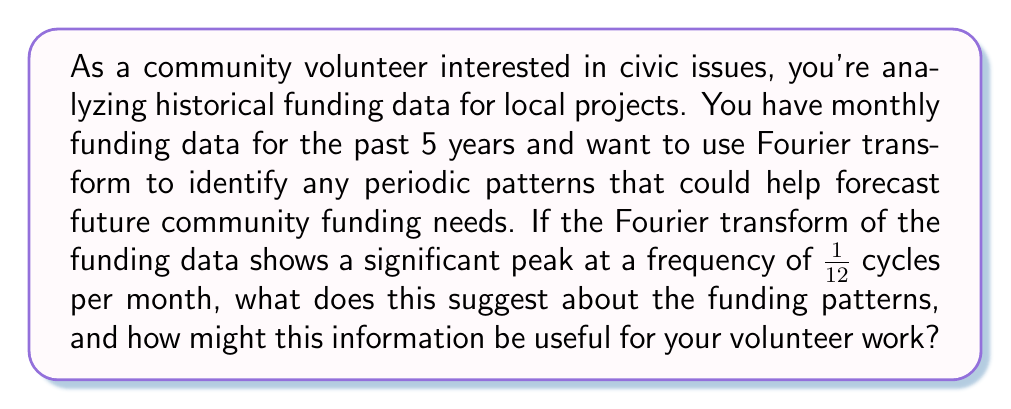Show me your answer to this math problem. To understand this question, let's break it down step-by-step:

1) Fourier transform basics:
   The Fourier transform decomposes a signal into its constituent frequencies. In this case, our "signal" is the monthly funding data over 5 years.

2) Interpreting the frequency:
   A frequency of $\frac{1}{12}$ cycles per month means:
   $$\text{Period} = \frac{1}{\text{Frequency}} = \frac{1}{\frac{1}{12}} = 12 \text{ months}$$

3) Meaning of the peak:
   A significant peak at this frequency indicates a strong periodic component in the funding data that repeats every 12 months, or annually.

4) Implications for funding patterns:
   This suggests that the community funding follows an annual cycle. There might be consistent increases or decreases in funding at the same time each year.

5) Usefulness for volunteer work:
   - Predictability: You can anticipate when funding might be more or less available.
   - Planning: Schedule projects or initiatives to align with periods of higher funding.
   - Advocacy: Use this information to argue for more consistent year-round funding if needed.
   - Grant applications: Time grant applications to coincide with periods of typically higher funding availability.

6) Connection to political awareness:
   Understanding these cycles can help you engage more effectively with local political issues related to budgeting and resource allocation.

This analysis demonstrates how mathematical tools like the Fourier transform can be applied to civic and economic data, providing valuable insights for community volunteers and politically engaged citizens.
Answer: The peak at a frequency of $\frac{1}{12}$ cycles per month suggests an annual (12-month) cycle in community funding patterns. This information can be used to better plan and advocate for community projects, time grant applications, and engage more effectively with local political issues related to budgeting and resource allocation. 